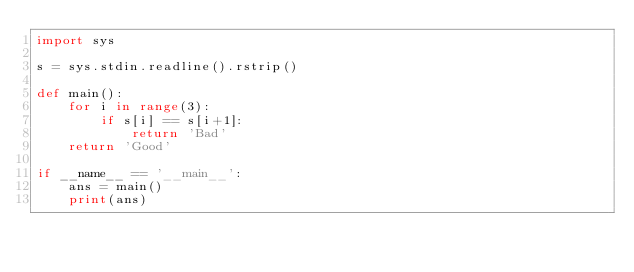<code> <loc_0><loc_0><loc_500><loc_500><_Python_>import sys

s = sys.stdin.readline().rstrip()

def main():
    for i in range(3):
        if s[i] == s[i+1]:
            return 'Bad'
    return 'Good'

if __name__ == '__main__':
    ans = main()
    print(ans)
</code> 